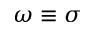Convert formula to latex. <formula><loc_0><loc_0><loc_500><loc_500>\omega \equiv \sigma</formula> 